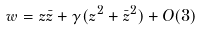Convert formula to latex. <formula><loc_0><loc_0><loc_500><loc_500>w = z \bar { z } + \gamma ( z ^ { 2 } + \bar { z } ^ { 2 } ) + O ( 3 )</formula> 